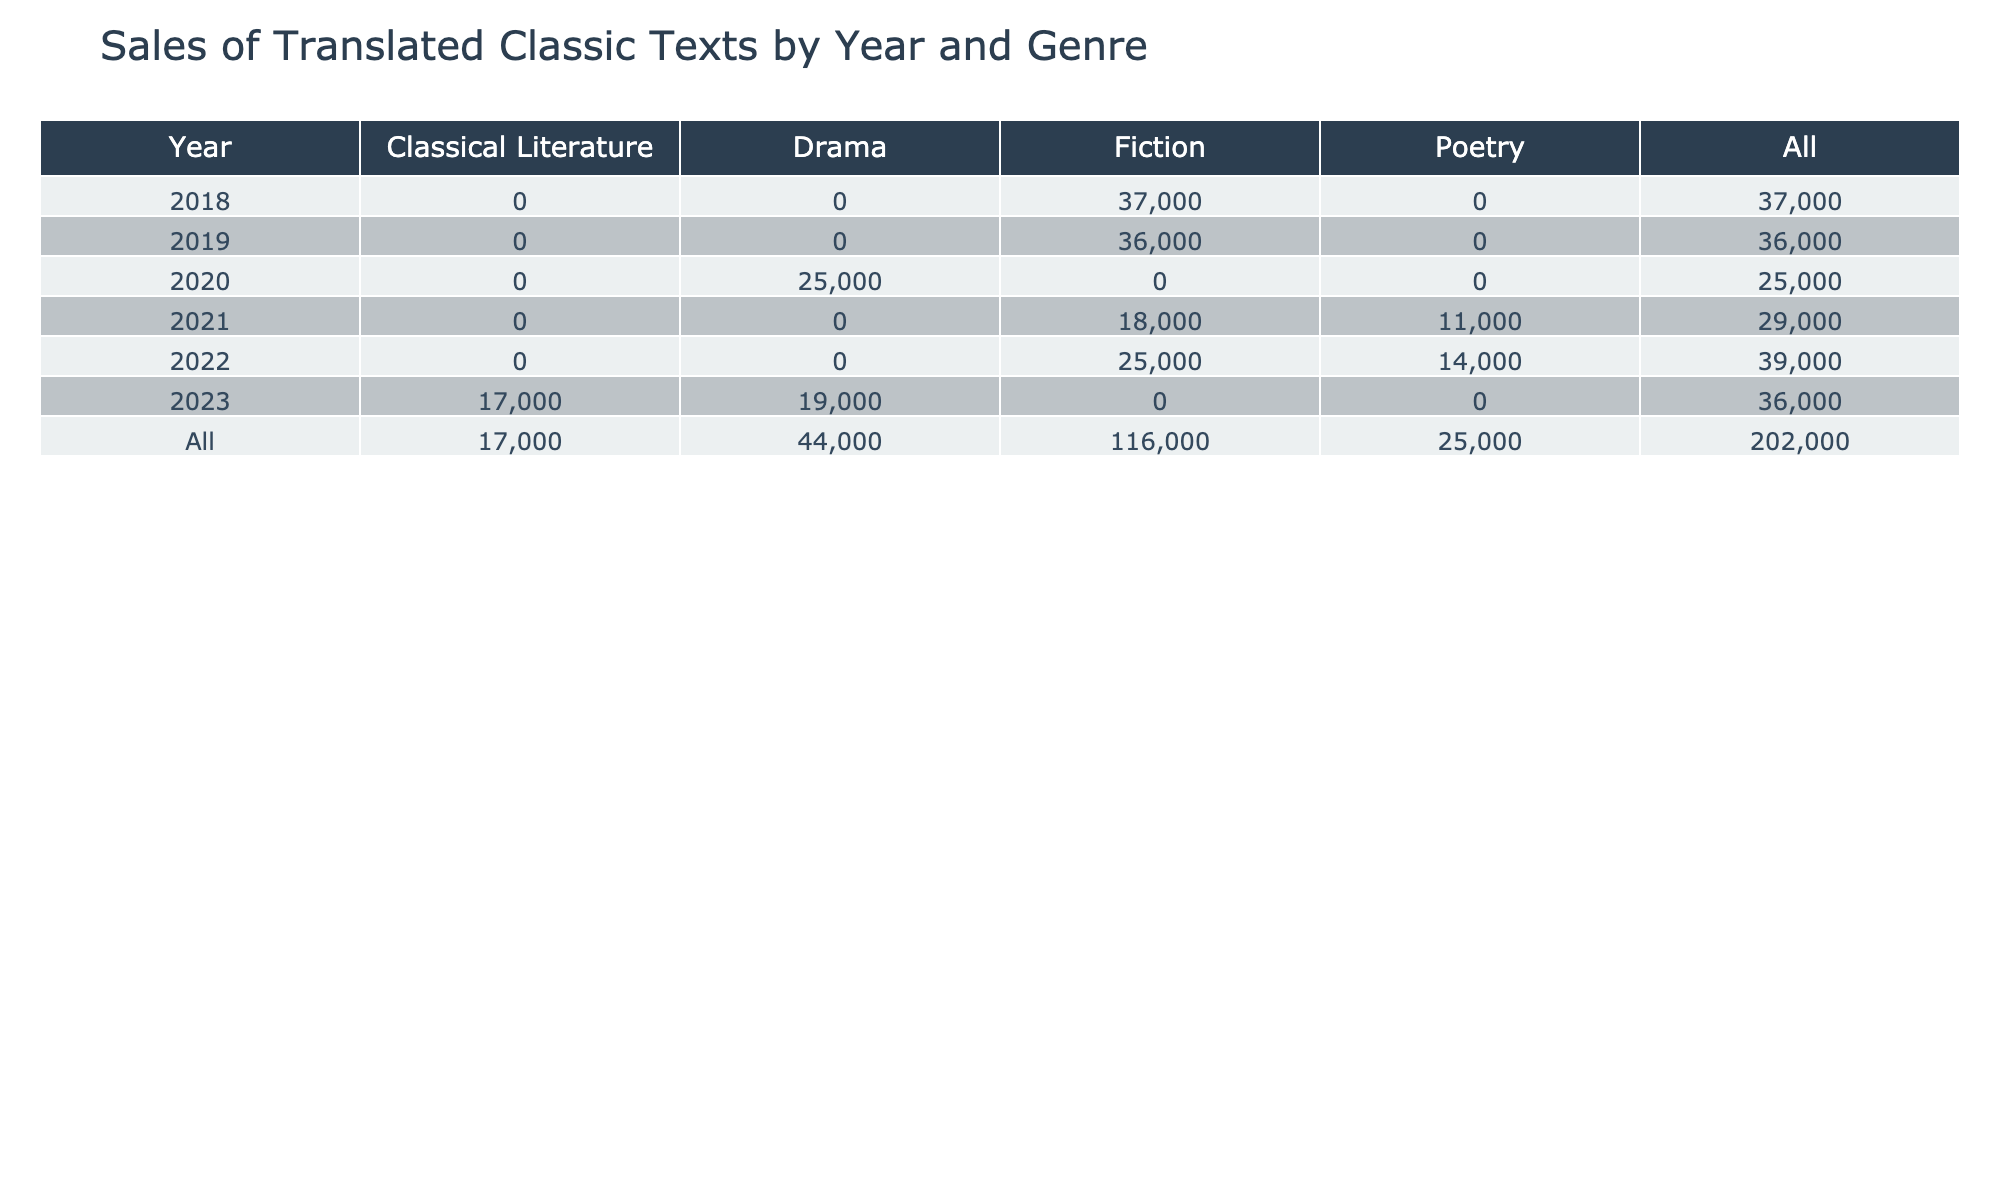What were the total sales in 2020? In 2020, there are two entries in the table: "Waiting for Godot" with sales of 12000 and "A Doll's House" with sales of 13000. Adding these two values together gives 12000 + 13000 = 25000.
Answer: 25000 Which genre had the highest sales in 2022? In 2022, the table shows sales for three genres: Poetry ("The Waste Land" with 14000), Fiction ("Jane Eyre" with 25000), and a total for all genres. The highest sales come from the Fiction category with 25000.
Answer: Fiction Was "Pride and Prejudice" more popular than "The Odyssey"? "Pride and Prejudice" had sales of 22000, whereas "The Odyssey" had sales of 17000. Since 22000 is greater than 17000, it indicates that "Pride and Prejudice" was indeed more popular.
Answer: Yes What is the sum of sales for all fiction titles from 2018 to 2022? The fiction titles sold during these years are "The Brothers Karamazov" (15000), "One Hundred Years of Solitude" (20000), "The Metamorphosis" (18000), "Pride and Prejudice" (22000), and "Jane Eyre" (25000). Summing these amounts gives 15000 + 20000 + 18000 + 22000 + 25000 = 108000.
Answer: 108000 In which year did drama titles have the highest sales? In the table, drama entries are listed for 2020 ("Waiting for Godot" with 12000), 2020 ("A Doll's House" with 13000), and 2023 ("Death of a Salesman" with 19000). The highest value among these is 19000 in 2023, indicating that year saw the highest drama sales.
Answer: 2023 What are the average sales for poetry titles based on the data? The poetry entries are "The Waste Land" (14000) in 2022 and "The Road Not Taken" (11000) in 2021. To find the average, sum these two values: 14000 + 11000 = 25000, and divide by the number of entries (2), resulting in an average of 25000 / 2 = 12500.
Answer: 12500 Did sales increase from 2018 to 2019 for fiction? In the years mentioned, fiction sales are 15000 in 2018 and 20000 in 2019. Since 20000 is greater than 15000, it indicates that sales indeed increased from 2018 to 2019.
Answer: Yes What is the total sales across all genres and years? To find the total sales across all genres and years, we sum the sales for each title listed in the table: 15000 + 20000 + 12000 + 18000 + 14000 + 17000 + 22000 + 16000 + 13000 + 11000 + 25000 + 19000 =  113000.
Answer: 113000 